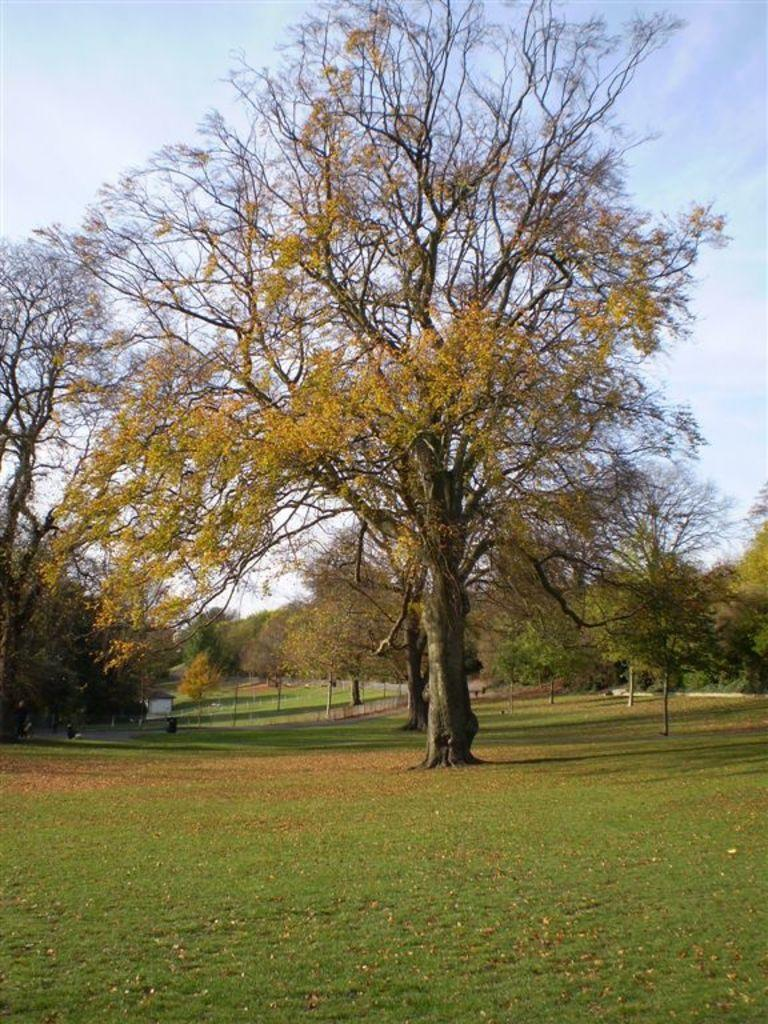What can be found in the garden in the image? There is a tree in the garden in the image. Can you describe the background of the image? There are many trees visible in the background of the image. How much smoke is coming from the tree in the image? There is no smoke coming from the tree in the image. 